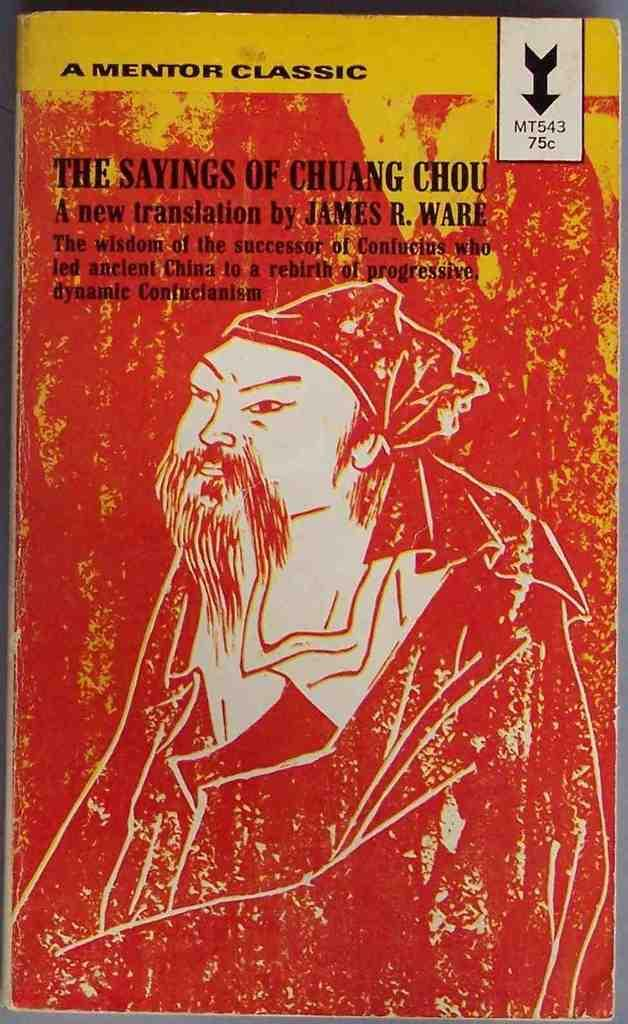<image>
Present a compact description of the photo's key features. The book The Sayings of Chuang Chou has a new translation by James R. Ware. 